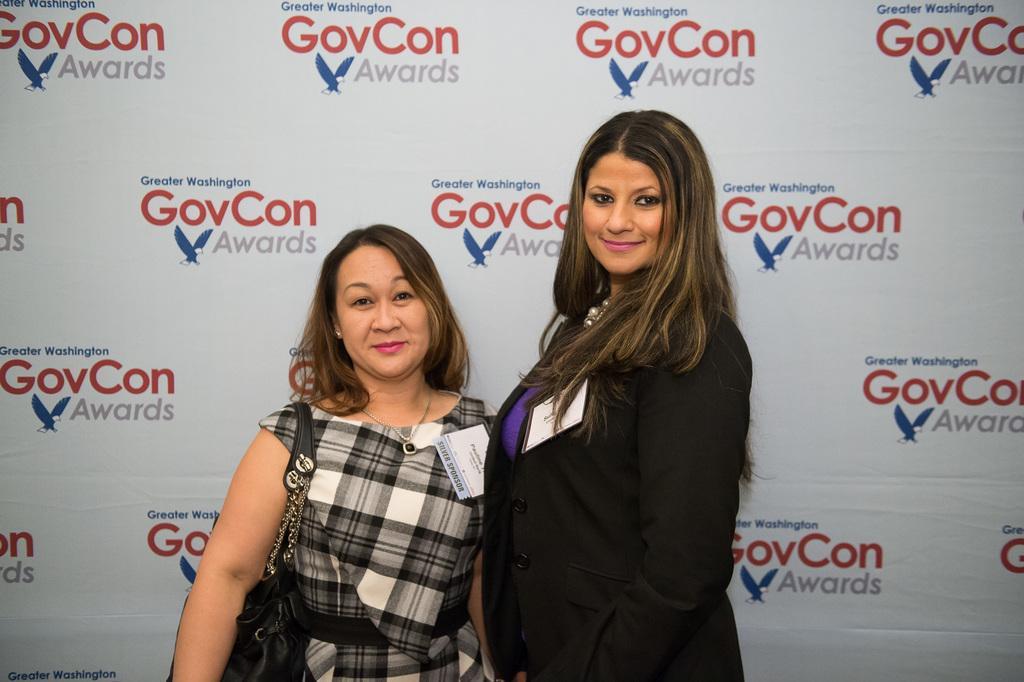Please provide a concise description of this image. In this image there are two people in the foreground. And There is a poster with some text in the background. 